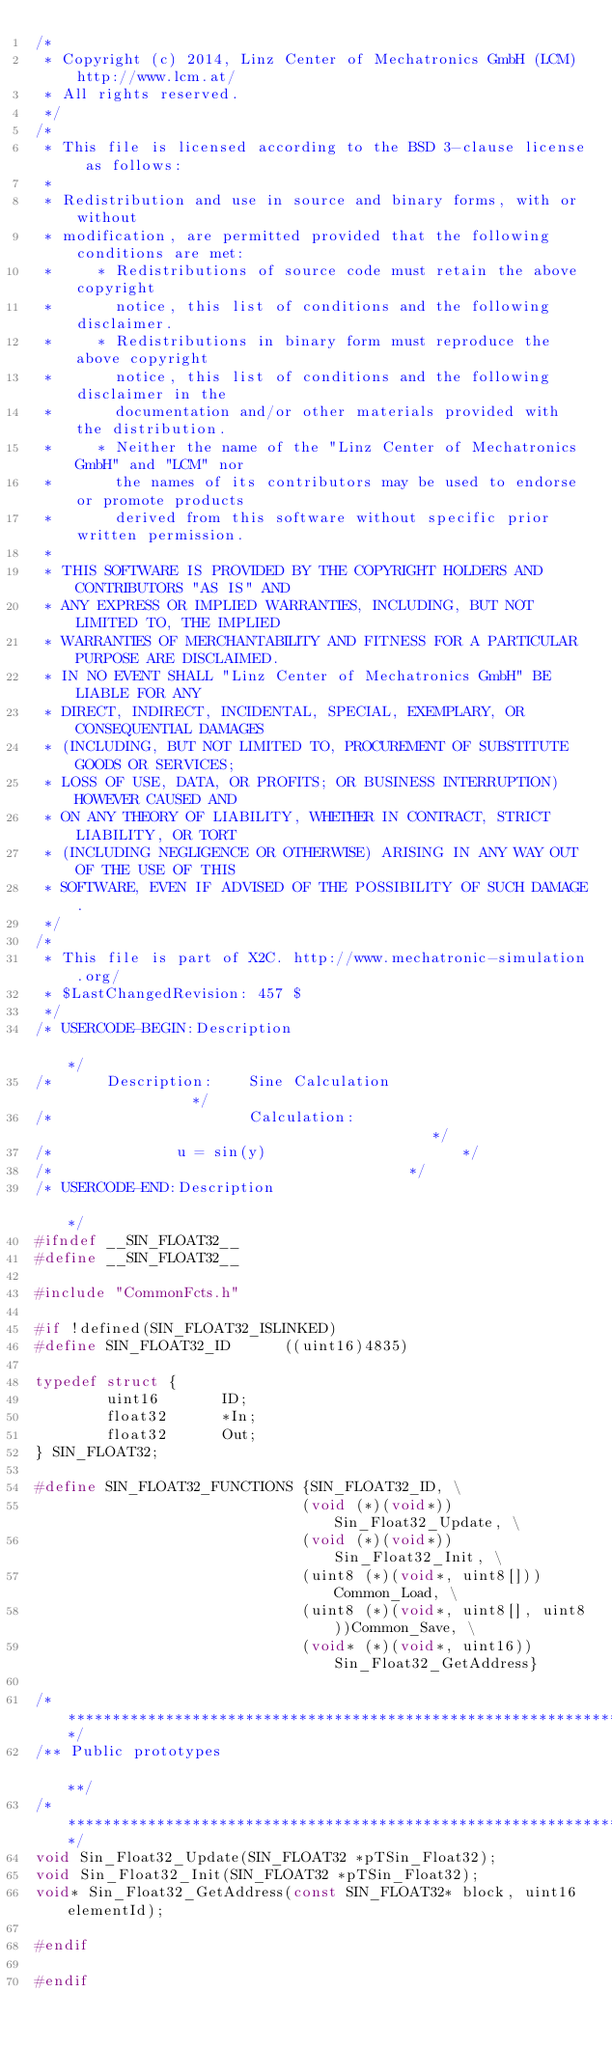Convert code to text. <code><loc_0><loc_0><loc_500><loc_500><_C_>/*
 * Copyright (c) 2014, Linz Center of Mechatronics GmbH (LCM) http://www.lcm.at/
 * All rights reserved.
 */
/*
 * This file is licensed according to the BSD 3-clause license as follows:
 * 
 * Redistribution and use in source and binary forms, with or without
 * modification, are permitted provided that the following conditions are met:
 *     * Redistributions of source code must retain the above copyright
 *       notice, this list of conditions and the following disclaimer.
 *     * Redistributions in binary form must reproduce the above copyright
 *       notice, this list of conditions and the following disclaimer in the
 *       documentation and/or other materials provided with the distribution.
 *     * Neither the name of the "Linz Center of Mechatronics GmbH" and "LCM" nor
 *       the names of its contributors may be used to endorse or promote products
 *       derived from this software without specific prior written permission.
 * 
 * THIS SOFTWARE IS PROVIDED BY THE COPYRIGHT HOLDERS AND CONTRIBUTORS "AS IS" AND
 * ANY EXPRESS OR IMPLIED WARRANTIES, INCLUDING, BUT NOT LIMITED TO, THE IMPLIED
 * WARRANTIES OF MERCHANTABILITY AND FITNESS FOR A PARTICULAR PURPOSE ARE DISCLAIMED.
 * IN NO EVENT SHALL "Linz Center of Mechatronics GmbH" BE LIABLE FOR ANY
 * DIRECT, INDIRECT, INCIDENTAL, SPECIAL, EXEMPLARY, OR CONSEQUENTIAL DAMAGES
 * (INCLUDING, BUT NOT LIMITED TO, PROCUREMENT OF SUBSTITUTE GOODS OR SERVICES;
 * LOSS OF USE, DATA, OR PROFITS; OR BUSINESS INTERRUPTION) HOWEVER CAUSED AND
 * ON ANY THEORY OF LIABILITY, WHETHER IN CONTRACT, STRICT LIABILITY, OR TORT
 * (INCLUDING NEGLIGENCE OR OTHERWISE) ARISING IN ANY WAY OUT OF THE USE OF THIS
 * SOFTWARE, EVEN IF ADVISED OF THE POSSIBILITY OF SUCH DAMAGE.
 */
/*
 * This file is part of X2C. http://www.mechatronic-simulation.org/
 * $LastChangedRevision: 457 $
 */
/* USERCODE-BEGIN:Description                                                                                         */
/*      Description:    Sine Calculation						              */
/*                      Calculation:                                          */
/* 							u = sin(y)								 		  */
/* 																			  */
/* USERCODE-END:Description                                                                                           */
#ifndef __SIN_FLOAT32__
#define __SIN_FLOAT32__

#include "CommonFcts.h"

#if !defined(SIN_FLOAT32_ISLINKED)
#define SIN_FLOAT32_ID      ((uint16)4835)

typedef struct {
        uint16       ID;
        float32      *In;
        float32      Out;
} SIN_FLOAT32;

#define SIN_FLOAT32_FUNCTIONS {SIN_FLOAT32_ID, \
                              (void (*)(void*))Sin_Float32_Update, \
                              (void (*)(void*))Sin_Float32_Init, \
                              (uint8 (*)(void*, uint8[]))Common_Load, \
                              (uint8 (*)(void*, uint8[], uint8))Common_Save, \
                              (void* (*)(void*, uint16))Sin_Float32_GetAddress}

/**********************************************************************************************************************/
/** Public prototypes                                                                                                **/
/**********************************************************************************************************************/
void Sin_Float32_Update(SIN_FLOAT32 *pTSin_Float32);
void Sin_Float32_Init(SIN_FLOAT32 *pTSin_Float32);
void* Sin_Float32_GetAddress(const SIN_FLOAT32* block, uint16 elementId);

#endif

#endif
</code> 